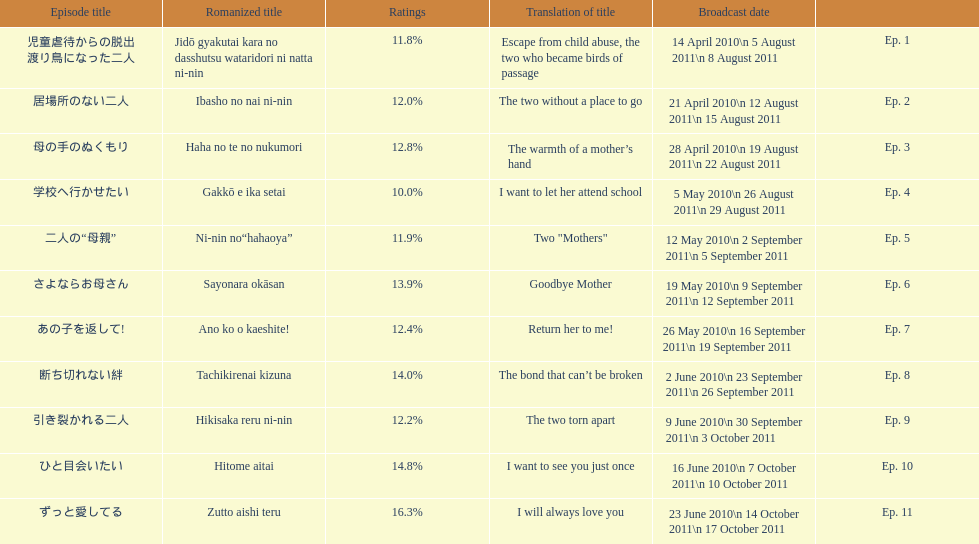What are the episodes of mother? 児童虐待からの脱出 渡り鳥になった二人, 居場所のない二人, 母の手のぬくもり, 学校へ行かせたい, 二人の“母親”, さよならお母さん, あの子を返して!, 断ち切れない絆, 引き裂かれる二人, ひと目会いたい, ずっと愛してる. What is the rating of episode 10? 14.8%. What is the other rating also in the 14 to 15 range? Ep. 8. 